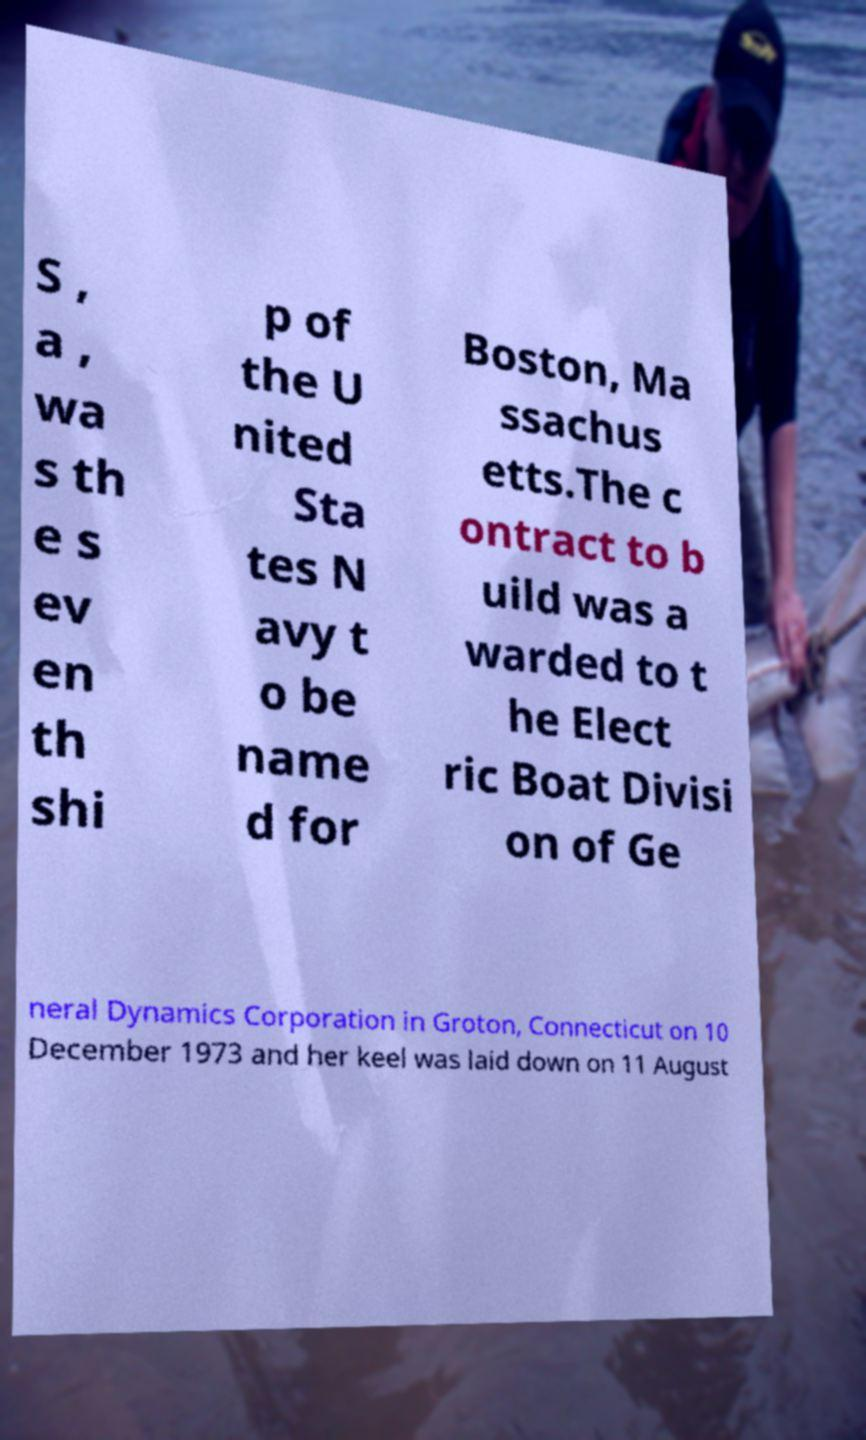I need the written content from this picture converted into text. Can you do that? S , a , wa s th e s ev en th shi p of the U nited Sta tes N avy t o be name d for Boston, Ma ssachus etts.The c ontract to b uild was a warded to t he Elect ric Boat Divisi on of Ge neral Dynamics Corporation in Groton, Connecticut on 10 December 1973 and her keel was laid down on 11 August 